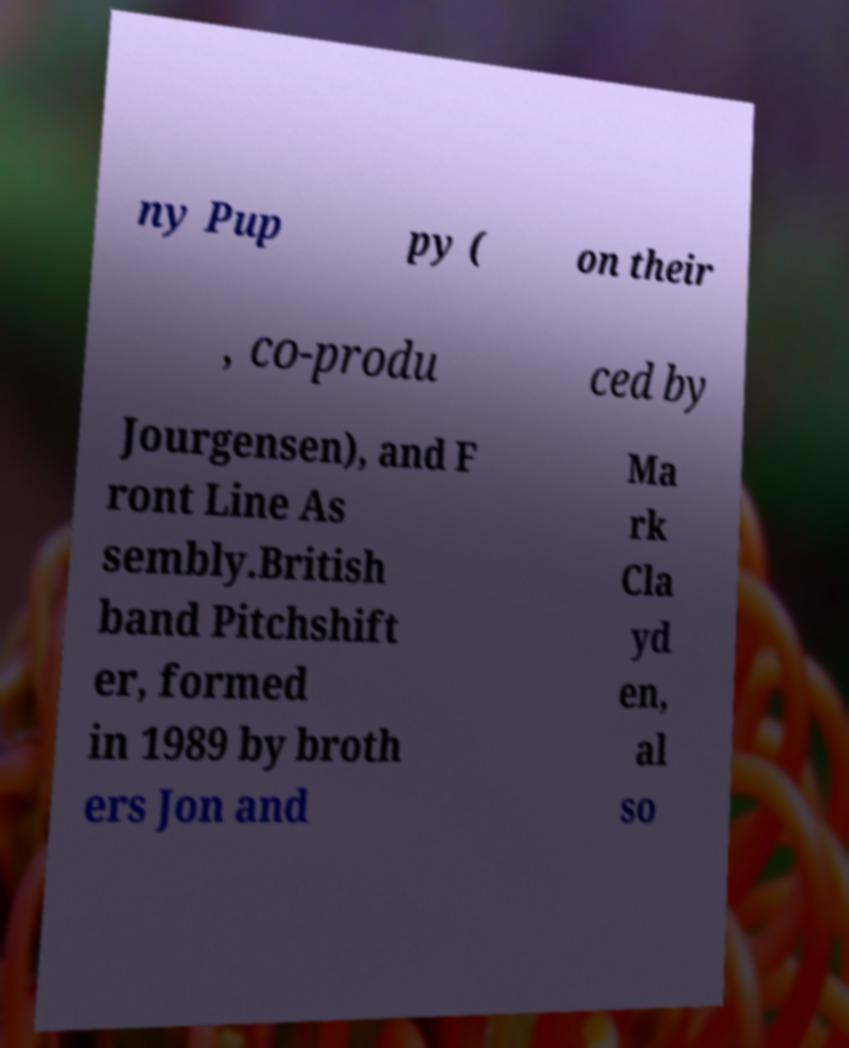What messages or text are displayed in this image? I need them in a readable, typed format. ny Pup py ( on their , co-produ ced by Jourgensen), and F ront Line As sembly.British band Pitchshift er, formed in 1989 by broth ers Jon and Ma rk Cla yd en, al so 